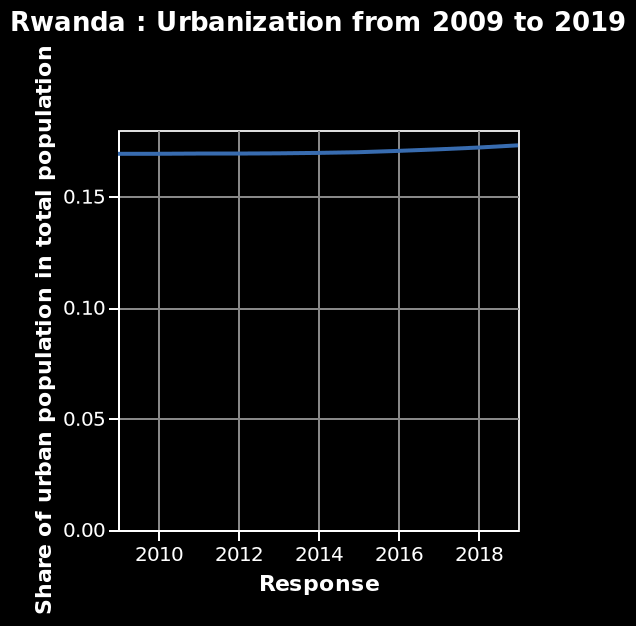<image>
What does the y-axis measure on the line graph? The y-axis measures the "Share of urban population in total population" on the line graph. 